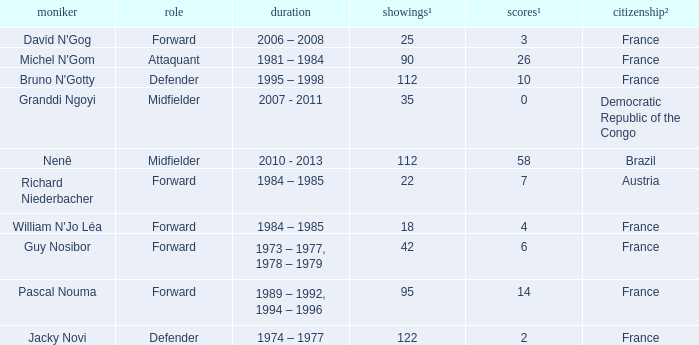How many games had less than 7 goals scored? 1.0. 